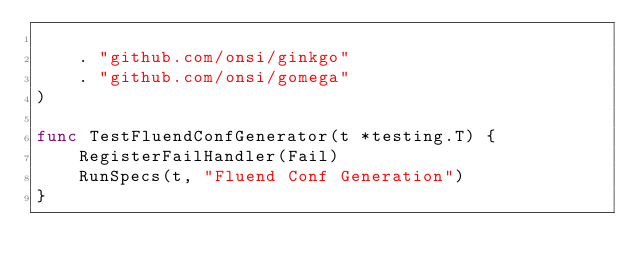<code> <loc_0><loc_0><loc_500><loc_500><_Go_>
	. "github.com/onsi/ginkgo"
	. "github.com/onsi/gomega"
)

func TestFluendConfGenerator(t *testing.T) {
	RegisterFailHandler(Fail)
	RunSpecs(t, "Fluend Conf Generation")
}
</code> 